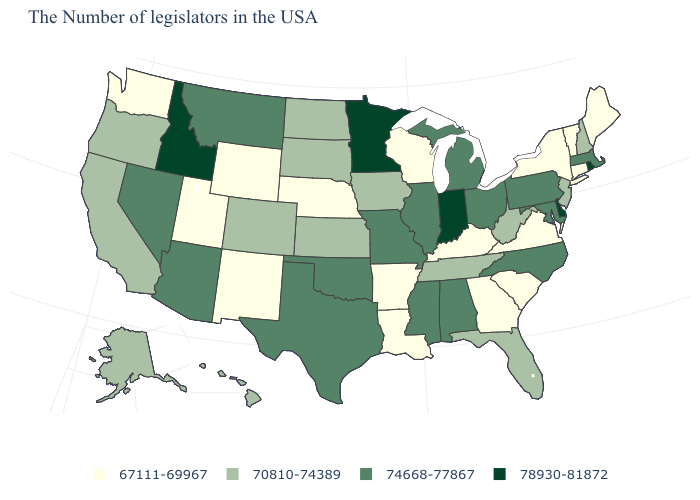What is the value of Maine?
Write a very short answer. 67111-69967. Among the states that border Nevada , does Idaho have the highest value?
Short answer required. Yes. Does New Mexico have the lowest value in the West?
Give a very brief answer. Yes. What is the value of Michigan?
Short answer required. 74668-77867. Name the states that have a value in the range 74668-77867?
Give a very brief answer. Massachusetts, Maryland, Pennsylvania, North Carolina, Ohio, Michigan, Alabama, Illinois, Mississippi, Missouri, Oklahoma, Texas, Montana, Arizona, Nevada. What is the highest value in states that border Massachusetts?
Quick response, please. 78930-81872. What is the highest value in the USA?
Write a very short answer. 78930-81872. Name the states that have a value in the range 70810-74389?
Give a very brief answer. New Hampshire, New Jersey, West Virginia, Florida, Tennessee, Iowa, Kansas, South Dakota, North Dakota, Colorado, California, Oregon, Alaska, Hawaii. Name the states that have a value in the range 67111-69967?
Keep it brief. Maine, Vermont, Connecticut, New York, Virginia, South Carolina, Georgia, Kentucky, Wisconsin, Louisiana, Arkansas, Nebraska, Wyoming, New Mexico, Utah, Washington. What is the value of Alabama?
Answer briefly. 74668-77867. Among the states that border South Carolina , does Georgia have the lowest value?
Short answer required. Yes. Which states hav the highest value in the South?
Concise answer only. Delaware. Among the states that border Ohio , which have the highest value?
Concise answer only. Indiana. What is the value of Indiana?
Concise answer only. 78930-81872. Among the states that border Wisconsin , does Minnesota have the lowest value?
Be succinct. No. 